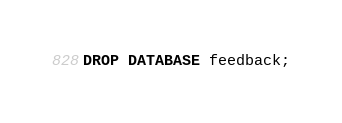<code> <loc_0><loc_0><loc_500><loc_500><_SQL_>DROP DATABASE feedback;</code> 